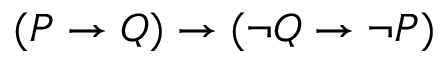<formula> <loc_0><loc_0><loc_500><loc_500>( P \to Q ) \to ( \neg Q \to \neg P )</formula> 